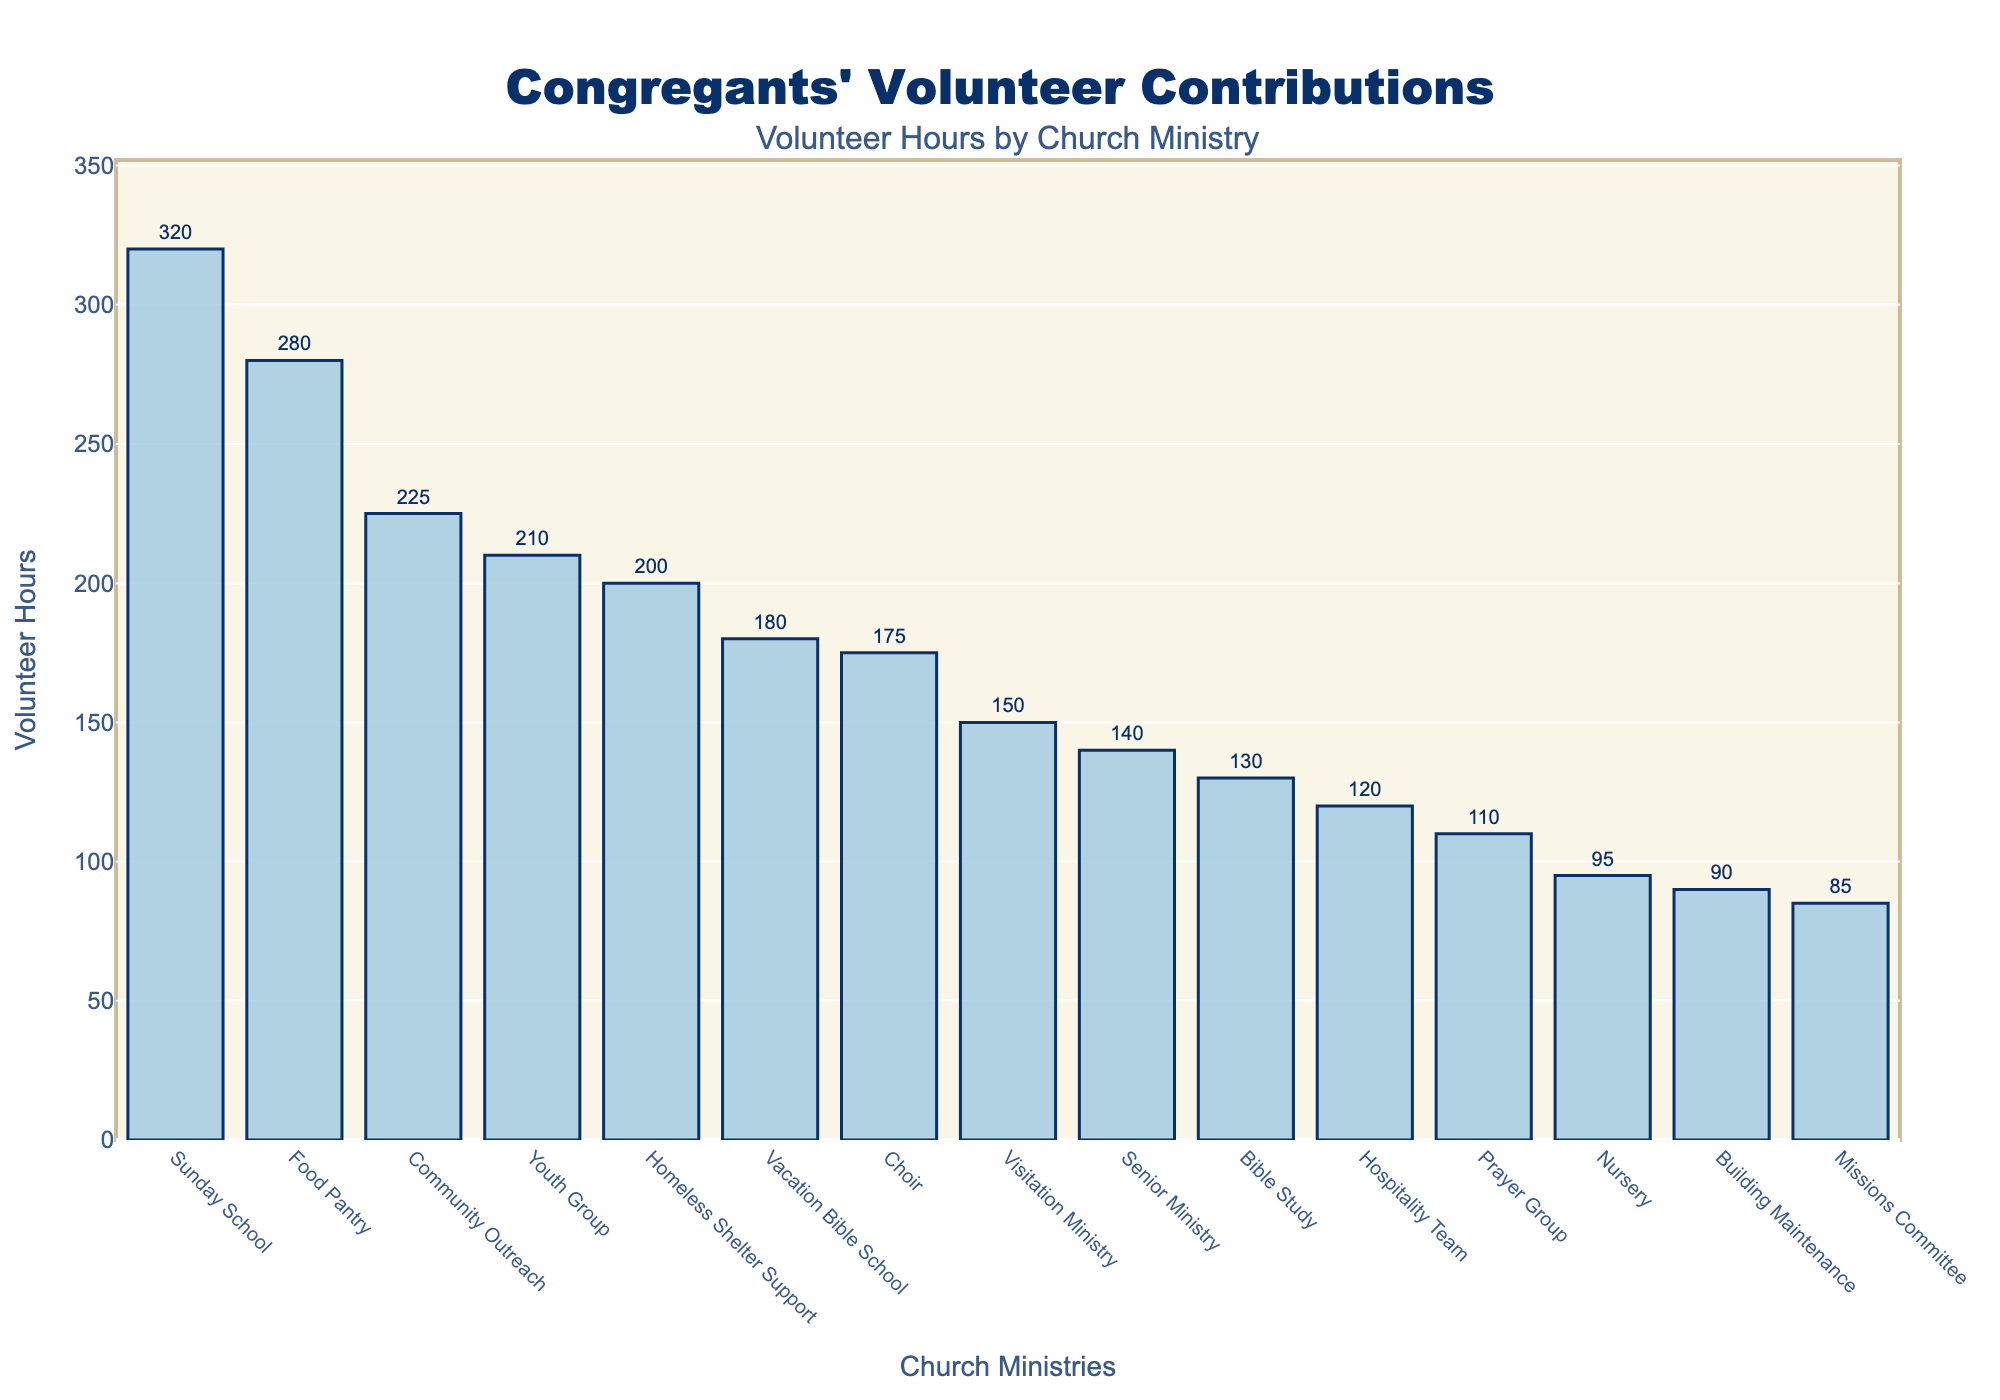Which ministry had the highest number of volunteer hours? The highest bar represents the ministry with the most volunteer hours. By looking at the bar chart, the Sunday School ministry has the highest bar.
Answer: Sunday School Which two ministries had the closest number of volunteer hours? Comparing the lengths of the bars visually, Choir and Visitation Ministry have relatively similar bar lengths. Both bars are close in height, with a small difference in volunteer hours between them.
Answer: Choir and Visitation Ministry What is the total number of volunteer hours contributed by the Youth Group and Community Outreach ministries combined? To find the total, add the volunteer hours of Youth Group (210) and Community Outreach (225) together. 210 + 225 = 435
Answer: 435 Which ministry had fewer volunteer hours: Hospitality Team or Bible Study? By comparing the bars representing Hospitality Team and Bible Study, the Hospitality Team has a shorter bar indicating fewer volunteer hours (120) compared to Bible Study (130).
Answer: Hospitality Team What is the difference in volunteer hours between the ministry with the highest and the lowest volunteer hours? The highest volunteer hours are from Sunday School (320) and the lowest are from Missions Committee (85). Calculate the difference: 320 - 85 = 235
Answer: 235 What is the average number of volunteer hours contributed by the top 3 ministries? Sum the hours of the top 3 ministries: Sunday School (320), Food Pantry (280), and Youth Group (210). Total is 320 + 280 + 210 = 810. The average is 810 ÷ 3 = 270
Answer: 270 How many ministries had 200 or more volunteer hours? Count the bars that reach or exceed 200 hours. These ministries are Sunday School, Food Pantry, Youth Group, Community Outreach, and Homeless Shelter Support.
Answer: 5 Which ministries had volunteer hours below 100? Identify the bars that fall below the 100-hour mark. The ministries are Building Maintenance (90), Nursery (95), and Missions Committee (85).
Answer: Building Maintenance, Nursery, Missions Committee By how much do the volunteer hours of the Sunday School ministry exceed those of the Choir ministry? Subtract the volunteer hours of Choir (175) from Sunday School (320). 320 - 175 = 145
Answer: 145 Are there more ministries with volunteer hours between 100 and 200 or fewer than 100? Count the ministries in each range by comparing bar heights. Between 100 and 200: Prayer Group (110), Bible Study (130), Hospitality Team (120), Senior Ministry (140), Vacation Bible School (180), Choir (175), Visitation Ministry (150). Below 100: Building Maintenance (90), Nursery (95), Missions Committee (85). There are more ministries between 100 and 200 hours.
Answer: Between 100 and 200 